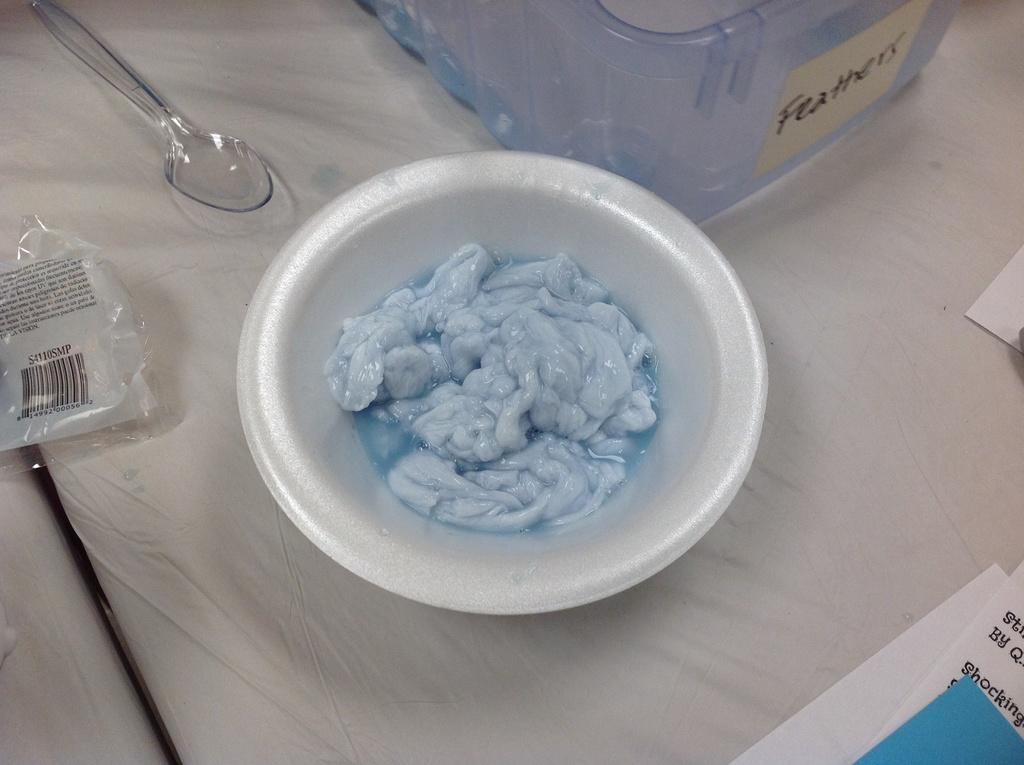What is in the bowl that is visible in the image? There is something in a bowl in the image, but the specific contents are not mentioned. What utensil is present in the image? There is a spoon in the image. What type of container is visible in the image? There is a container in the image. What is covering the container in the image? There is a cover in the image. What type of paper items are present in the image? There are papers in the image. What type of cars are parked in the image? There are no cars present in the image. What type of furniture is visible in the image? There is no furniture visible in the image. 